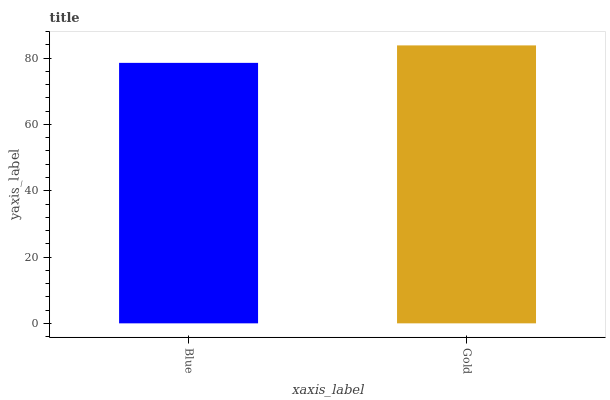Is Blue the minimum?
Answer yes or no. Yes. Is Gold the maximum?
Answer yes or no. Yes. Is Gold the minimum?
Answer yes or no. No. Is Gold greater than Blue?
Answer yes or no. Yes. Is Blue less than Gold?
Answer yes or no. Yes. Is Blue greater than Gold?
Answer yes or no. No. Is Gold less than Blue?
Answer yes or no. No. Is Gold the high median?
Answer yes or no. Yes. Is Blue the low median?
Answer yes or no. Yes. Is Blue the high median?
Answer yes or no. No. Is Gold the low median?
Answer yes or no. No. 